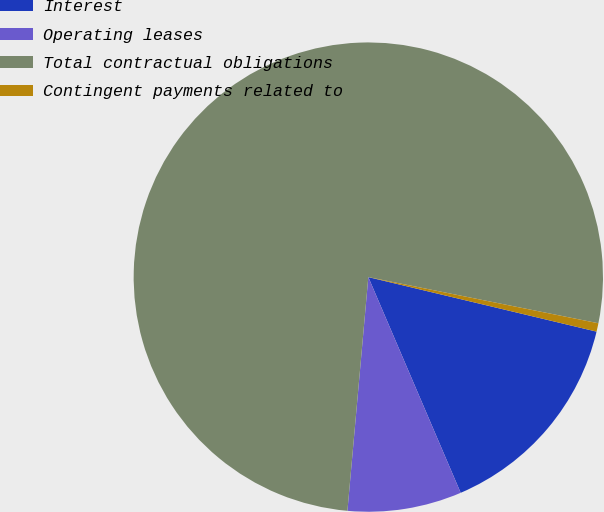Convert chart. <chart><loc_0><loc_0><loc_500><loc_500><pie_chart><fcel>Interest<fcel>Operating leases<fcel>Total contractual obligations<fcel>Contingent payments related to<nl><fcel>14.83%<fcel>7.86%<fcel>76.74%<fcel>0.58%<nl></chart> 